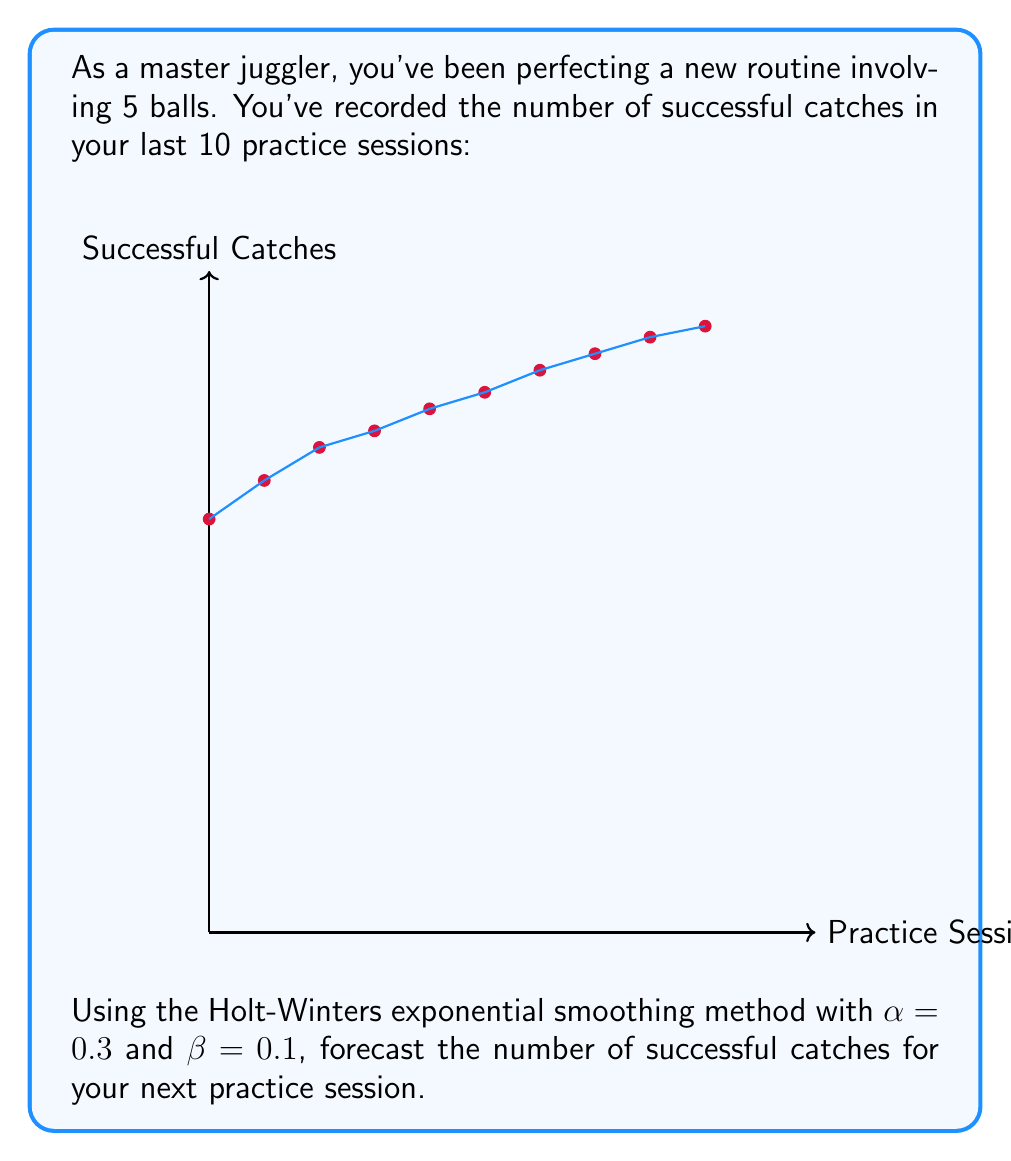Can you answer this question? To forecast using the Holt-Winters method (without seasonality), we need to calculate the level ($L_t$) and trend ($T_t$) components for each period, then use these to make our forecast.

The formulas for the Holt-Winters method are:

Level: $L_t = \alpha Y_t + (1-\alpha)(L_{t-1} + T_{t-1})$
Trend: $T_t = \beta(L_t - L_{t-1}) + (1-\beta)T_{t-1}$
Forecast: $F_{t+1} = L_t + T_t$

Where $Y_t$ is the observed value at time $t$, $\alpha$ is the level smoothing factor, and $\beta$ is the trend smoothing factor.

Let's calculate for the last few periods:

Period 8:
$L_8 = 0.3(105) + 0.7(102 + 3.3) = 105.21$
$T_8 = 0.1(105.21 - 102) + 0.9(3.3) = 3.25$

Period 9:
$L_9 = 0.3(108) + 0.7(105.21 + 3.25) = 108.02$
$T_9 = 0.1(108.02 - 105.21) + 0.9(3.25) = 3.21$

Period 10:
$L_{10} = 0.3(110) + 0.7(108.02 + 3.21) = 110.36$
$T_{10} = 0.1(110.36 - 108.02) + 0.9(3.21) = 3.12$

Now we can forecast for period 11:

$F_{11} = L_{10} + T_{10} = 110.36 + 3.12 = 113.48$

Rounding to the nearest whole number (as we can't have partial catches), our forecast is 113 successful catches for the next practice session.
Answer: 113 catches 